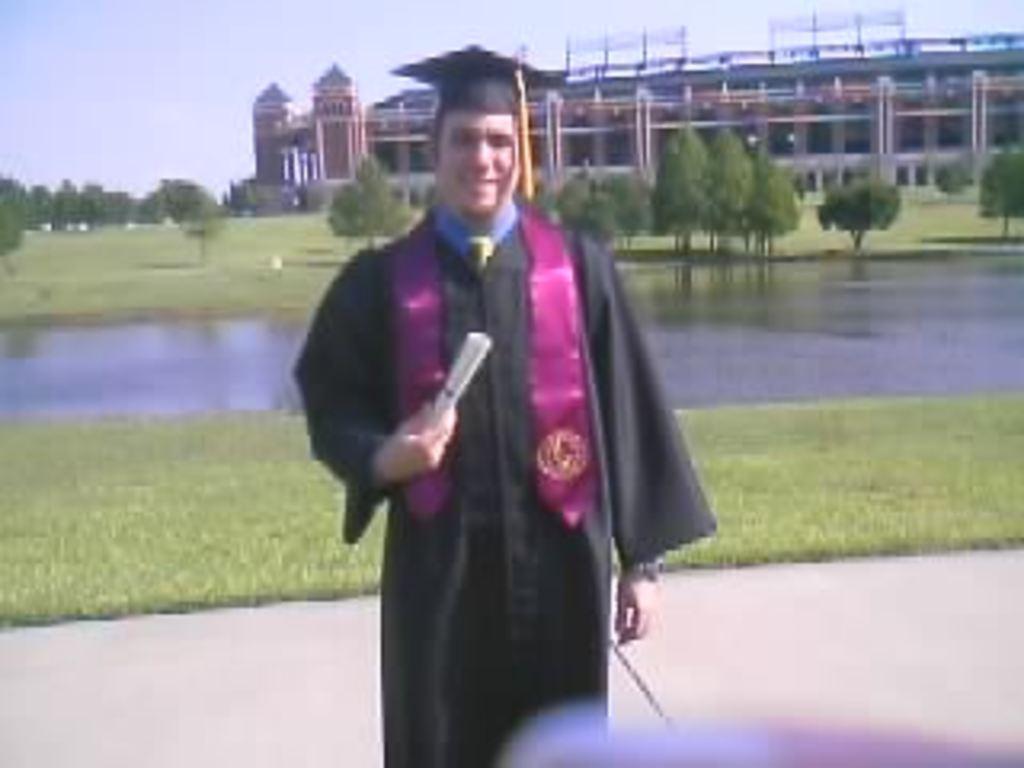Describe this image in one or two sentences. There is one man standing and wearing a graduation gown at the bottom of this image. We can see a surface of water, trees and a grassy land in the middle of this image. We can see a building at the top of this image and the sky is in the background. 